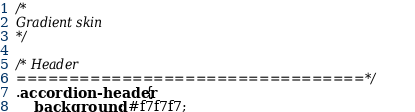Convert code to text. <code><loc_0><loc_0><loc_500><loc_500><_CSS_>/*
Gradient skin
*/

/* Header
=================================*/
.accordion-header{
	background: #f7f7f7;</code> 